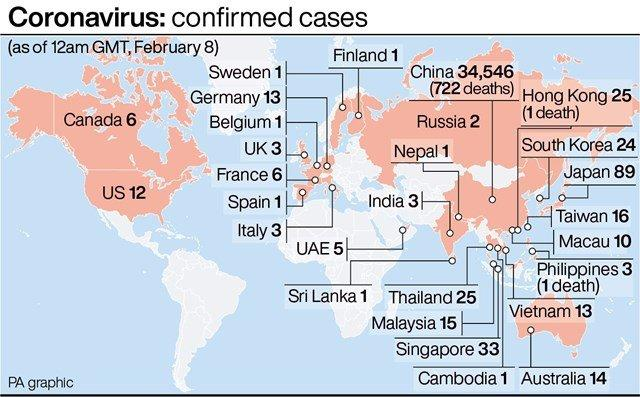Give some essential details in this illustration. As of February 8, the number of fatalities due to COVID-19 in the Philippines is 1. As of February 8, China has reported the highest number of COVID-19 cases globally. There were 33 confirmed cases of COVID-19 reported in Singapore as of February 8. Japan has reported the second highest number of COVID-19 cases globally as of February 8. As of February 8, the number of fatalities due to COVID-19 in Hong Kong is 1. 